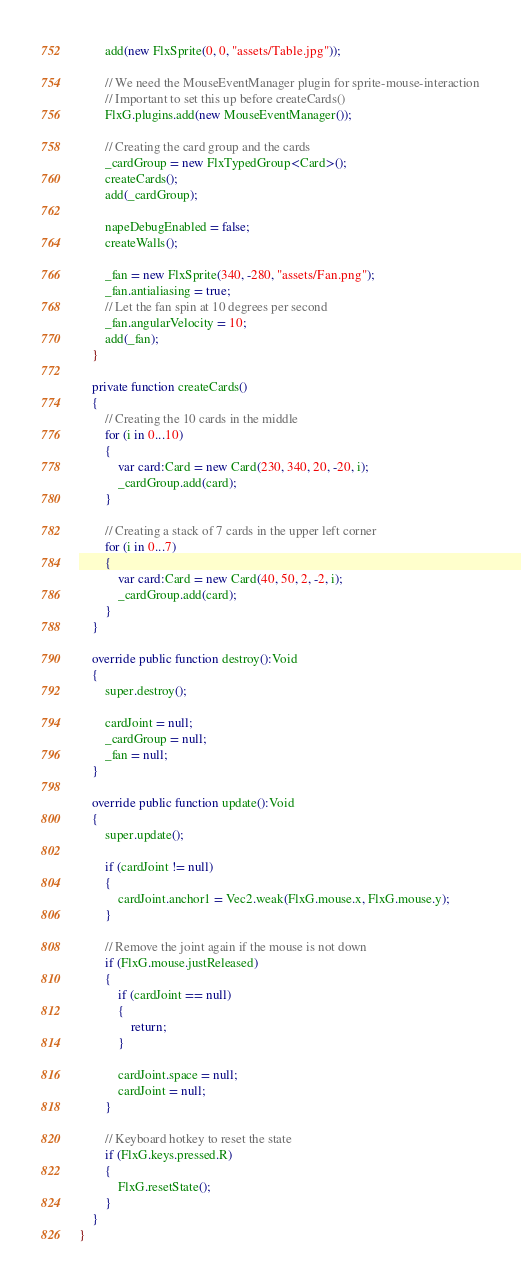Convert code to text. <code><loc_0><loc_0><loc_500><loc_500><_Haxe_>		add(new FlxSprite(0, 0, "assets/Table.jpg"));
		
		// We need the MouseEventManager plugin for sprite-mouse-interaction
		// Important to set this up before createCards()
		FlxG.plugins.add(new MouseEventManager());
		
		// Creating the card group and the cards
		_cardGroup = new FlxTypedGroup<Card>();
		createCards();
		add(_cardGroup);

		napeDebugEnabled = false;
		createWalls();
		
		_fan = new FlxSprite(340, -280, "assets/Fan.png");
		_fan.antialiasing = true;
		// Let the fan spin at 10 degrees per second
		_fan.angularVelocity = 10;
		add(_fan);
	}
	
	private function createCards() 
	{
		// Creating the 10 cards in the middle
		for (i in 0...10)
		{
			var card:Card = new Card(230, 340, 20, -20, i);
			_cardGroup.add(card);
		}
		
		// Creating a stack of 7 cards in the upper left corner
		for (i in 0...7)
		{
			var card:Card = new Card(40, 50, 2, -2, i);
			_cardGroup.add(card);
		}
	}
	
	override public function destroy():Void
	{
		super.destroy();
		
		cardJoint = null;
		_cardGroup = null;
		_fan = null;
	}
	
	override public function update():Void 
	{
		super.update();
		
		if (cardJoint != null)
		{
			cardJoint.anchor1 = Vec2.weak(FlxG.mouse.x, FlxG.mouse.y);
		}
		
		// Remove the joint again if the mouse is not down
		if (FlxG.mouse.justReleased)
		{
			if (cardJoint == null)
			{
				return;
			}
			
			cardJoint.space = null;
			cardJoint = null;
		}
		
		// Keyboard hotkey to reset the state
		if (FlxG.keys.pressed.R)
		{
			FlxG.resetState();
		}
	}
}</code> 